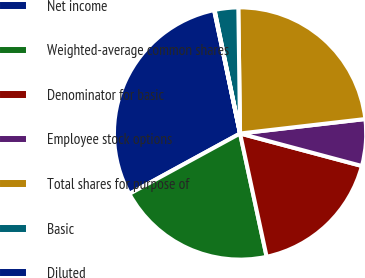Convert chart. <chart><loc_0><loc_0><loc_500><loc_500><pie_chart><fcel>Net income<fcel>Weighted-average common shares<fcel>Denominator for basic<fcel>Employee stock options<fcel>Total shares for purpose of<fcel>Basic<fcel>Diluted<nl><fcel>29.65%<fcel>20.43%<fcel>17.47%<fcel>5.98%<fcel>23.39%<fcel>3.02%<fcel>0.06%<nl></chart> 